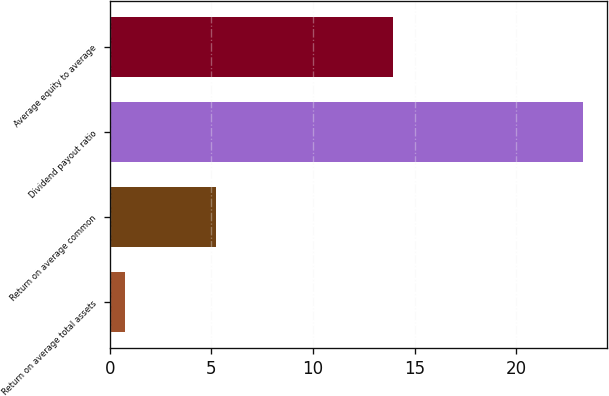Convert chart. <chart><loc_0><loc_0><loc_500><loc_500><bar_chart><fcel>Return on average total assets<fcel>Return on average common<fcel>Dividend payout ratio<fcel>Average equity to average<nl><fcel>0.73<fcel>5.23<fcel>23.3<fcel>13.93<nl></chart> 